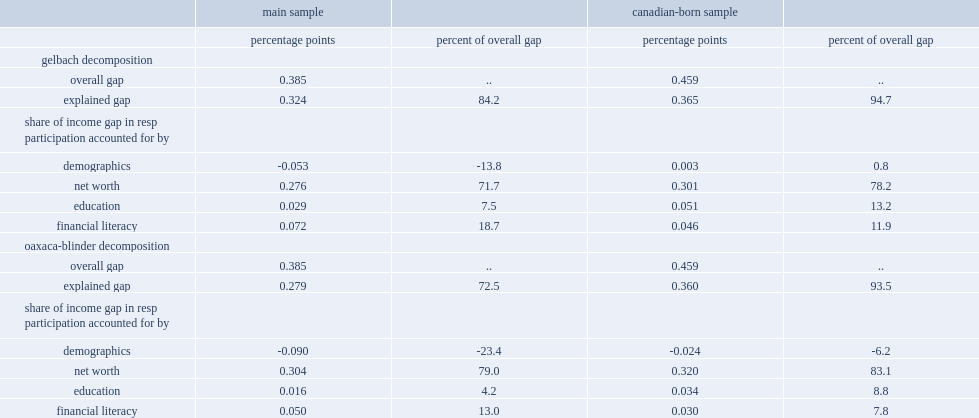How many percentage points out of the 38.5 percentage point gap in resp participationcan can be explained by the differences in financial literacy proficiency between high- and low-income parents? 0.072. Parse the full table. {'header': ['', 'main sample', '', 'canadian-born sample', ''], 'rows': [['', 'percentage points', 'percent of overall gap', 'percentage points', 'percent of overall gap'], ['gelbach decomposition', '', '', '', ''], ['overall gap', '0.385', '..', '0.459', '..'], ['explained gap', '0.324', '84.2', '0.365', '94.7'], ['share of income gap in resp participation accounted for by', '', '', '', ''], ['demographics', '-0.053', '-13.8', '0.003', '0.8'], ['net worth', '0.276', '71.7', '0.301', '78.2'], ['education', '0.029', '7.5', '0.051', '13.2'], ['financial literacy', '0.072', '18.7', '0.046', '11.9'], ['oaxaca-blinder decomposition', '', '', '', ''], ['overall gap', '0.385', '..', '0.459', '..'], ['explained gap', '0.279', '72.5', '0.360', '93.5'], ['share of income gap in resp participation accounted for by', '', '', '', ''], ['demographics', '-0.090', '-23.4', '-0.024', '-6.2'], ['net worth', '0.304', '79.0', '0.320', '83.1'], ['education', '0.016', '4.2', '0.034', '8.8'], ['financial literacy', '0.050', '13.0', '0.030', '7.8']]} 